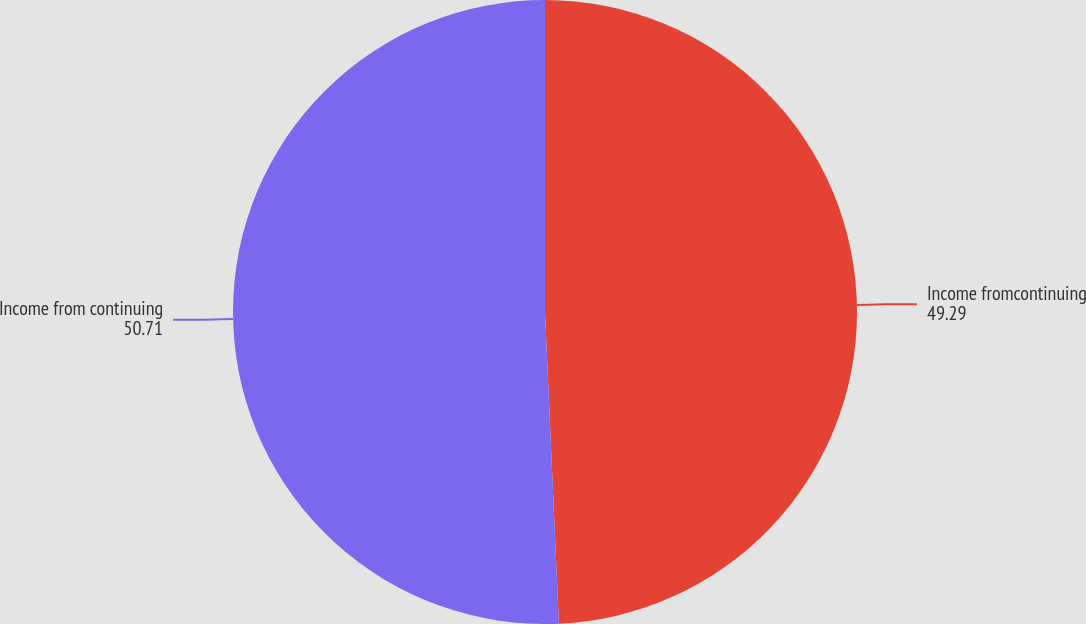Convert chart. <chart><loc_0><loc_0><loc_500><loc_500><pie_chart><fcel>Income fromcontinuing<fcel>Income from continuing<nl><fcel>49.29%<fcel>50.71%<nl></chart> 